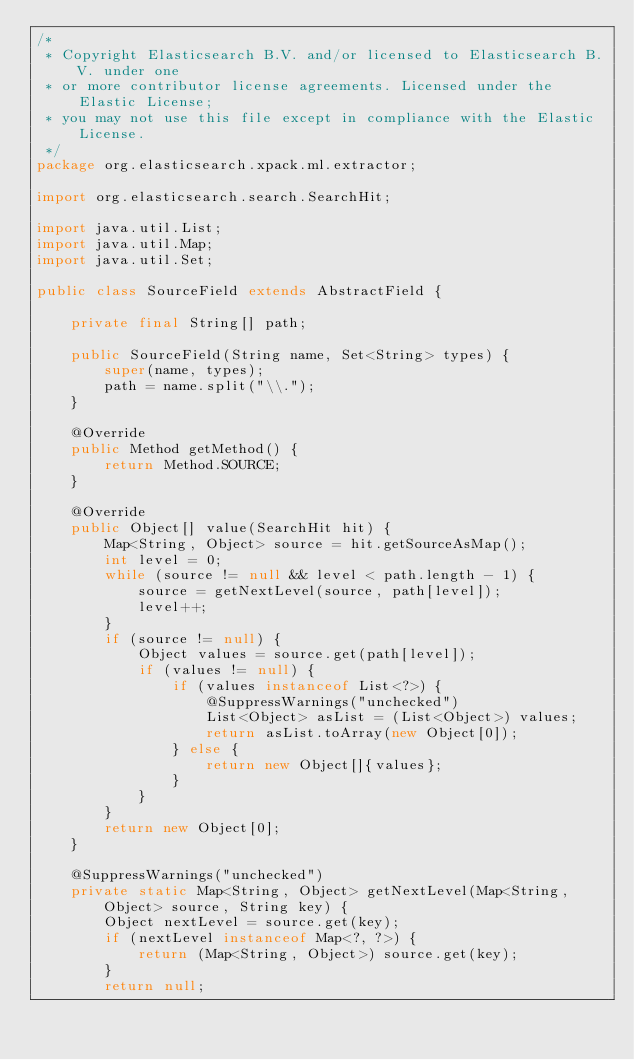Convert code to text. <code><loc_0><loc_0><loc_500><loc_500><_Java_>/*
 * Copyright Elasticsearch B.V. and/or licensed to Elasticsearch B.V. under one
 * or more contributor license agreements. Licensed under the Elastic License;
 * you may not use this file except in compliance with the Elastic License.
 */
package org.elasticsearch.xpack.ml.extractor;

import org.elasticsearch.search.SearchHit;

import java.util.List;
import java.util.Map;
import java.util.Set;

public class SourceField extends AbstractField {

    private final String[] path;

    public SourceField(String name, Set<String> types) {
        super(name, types);
        path = name.split("\\.");
    }

    @Override
    public Method getMethod() {
        return Method.SOURCE;
    }

    @Override
    public Object[] value(SearchHit hit) {
        Map<String, Object> source = hit.getSourceAsMap();
        int level = 0;
        while (source != null && level < path.length - 1) {
            source = getNextLevel(source, path[level]);
            level++;
        }
        if (source != null) {
            Object values = source.get(path[level]);
            if (values != null) {
                if (values instanceof List<?>) {
                    @SuppressWarnings("unchecked")
                    List<Object> asList = (List<Object>) values;
                    return asList.toArray(new Object[0]);
                } else {
                    return new Object[]{values};
                }
            }
        }
        return new Object[0];
    }

    @SuppressWarnings("unchecked")
    private static Map<String, Object> getNextLevel(Map<String, Object> source, String key) {
        Object nextLevel = source.get(key);
        if (nextLevel instanceof Map<?, ?>) {
            return (Map<String, Object>) source.get(key);
        }
        return null;</code> 